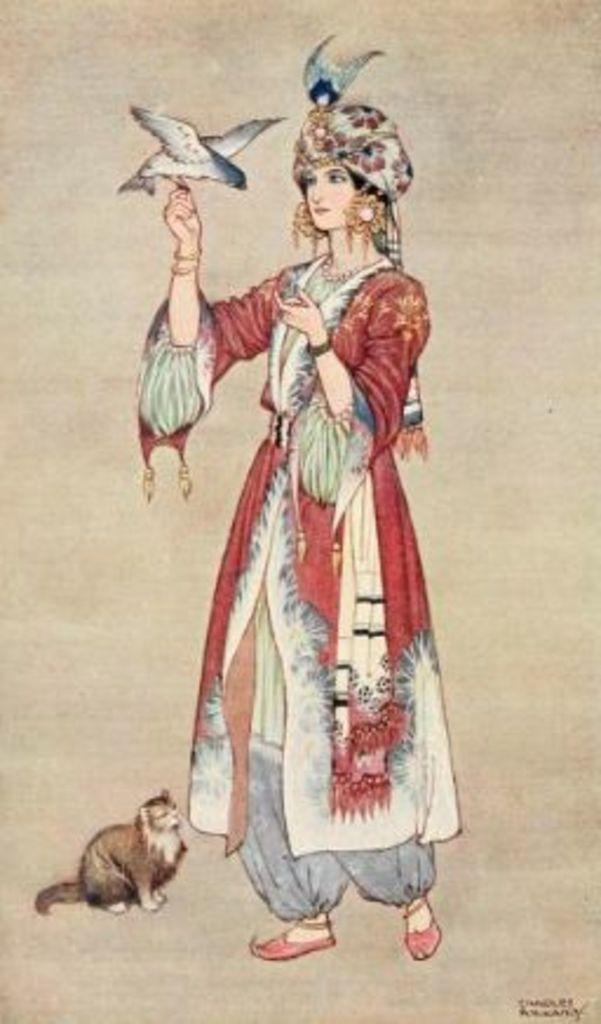Describe this image in one or two sentences. In this picture I can see the depiction picture of a woman, who is standing and I see that she is holding a bird and I see a cat on the left bottom of this image and I see the watermark on the right bottom corner of this image. 